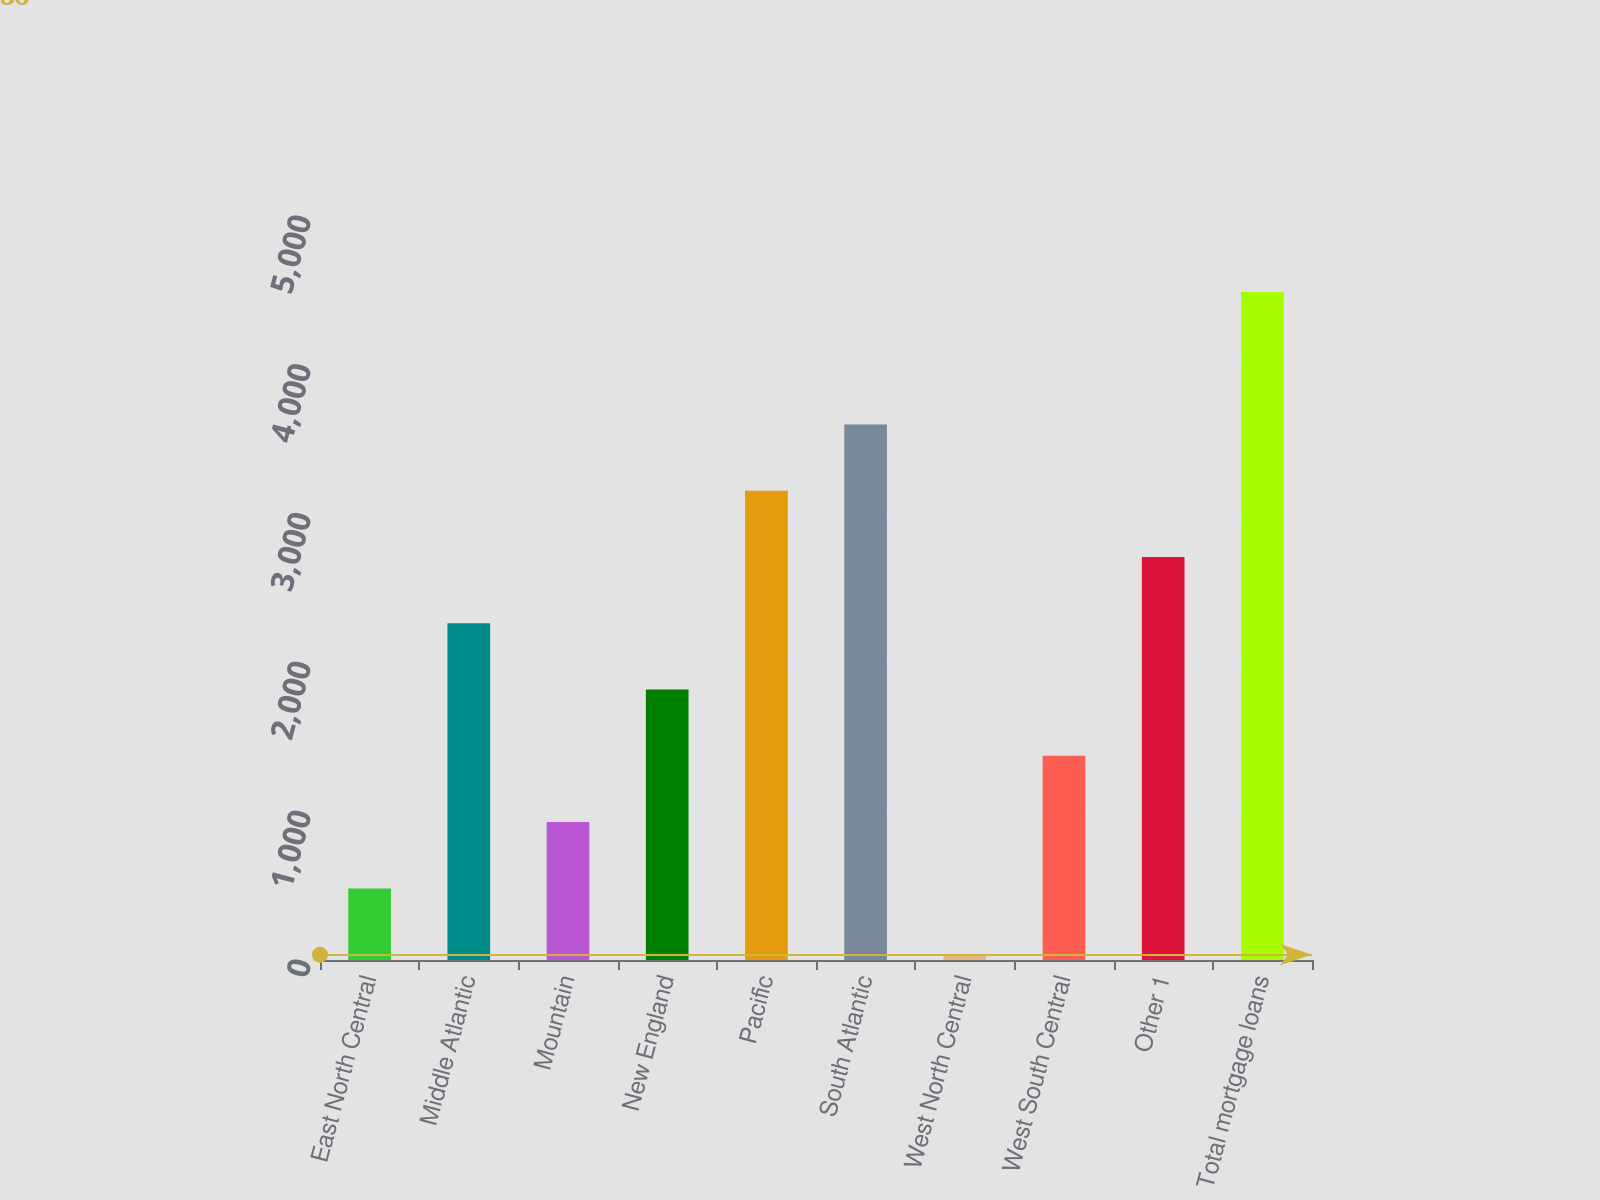Convert chart. <chart><loc_0><loc_0><loc_500><loc_500><bar_chart><fcel>East North Central<fcel>Middle Atlantic<fcel>Mountain<fcel>New England<fcel>Pacific<fcel>South Atlantic<fcel>West North Central<fcel>West South Central<fcel>Other 1<fcel>Total mortgage loans<nl><fcel>481.3<fcel>2262.5<fcel>926.6<fcel>1817.2<fcel>3153.1<fcel>3598.4<fcel>36<fcel>1371.9<fcel>2707.8<fcel>4489<nl></chart> 